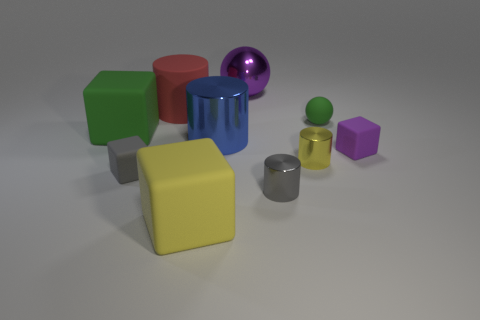What number of cubes are either green rubber objects or red things?
Your answer should be very brief. 1. What material is the tiny cube that is the same color as the big ball?
Keep it short and to the point. Rubber. Is the number of small green objects behind the purple matte thing less than the number of rubber objects that are behind the large red rubber cylinder?
Your answer should be compact. No. How many objects are either tiny gray things on the right side of the big purple thing or tiny yellow metallic things?
Provide a short and direct response. 2. What shape is the big matte thing in front of the tiny metallic cylinder in front of the gray matte block?
Provide a short and direct response. Cube. Is there a purple matte block of the same size as the blue metal cylinder?
Offer a terse response. No. Is the number of small purple matte cubes greater than the number of small matte blocks?
Provide a short and direct response. No. Do the rubber thing left of the small gray rubber block and the cube on the right side of the green sphere have the same size?
Offer a very short reply. No. How many small objects are both in front of the tiny purple rubber thing and behind the blue cylinder?
Your response must be concise. 0. The small matte object that is the same shape as the large purple thing is what color?
Provide a short and direct response. Green. 